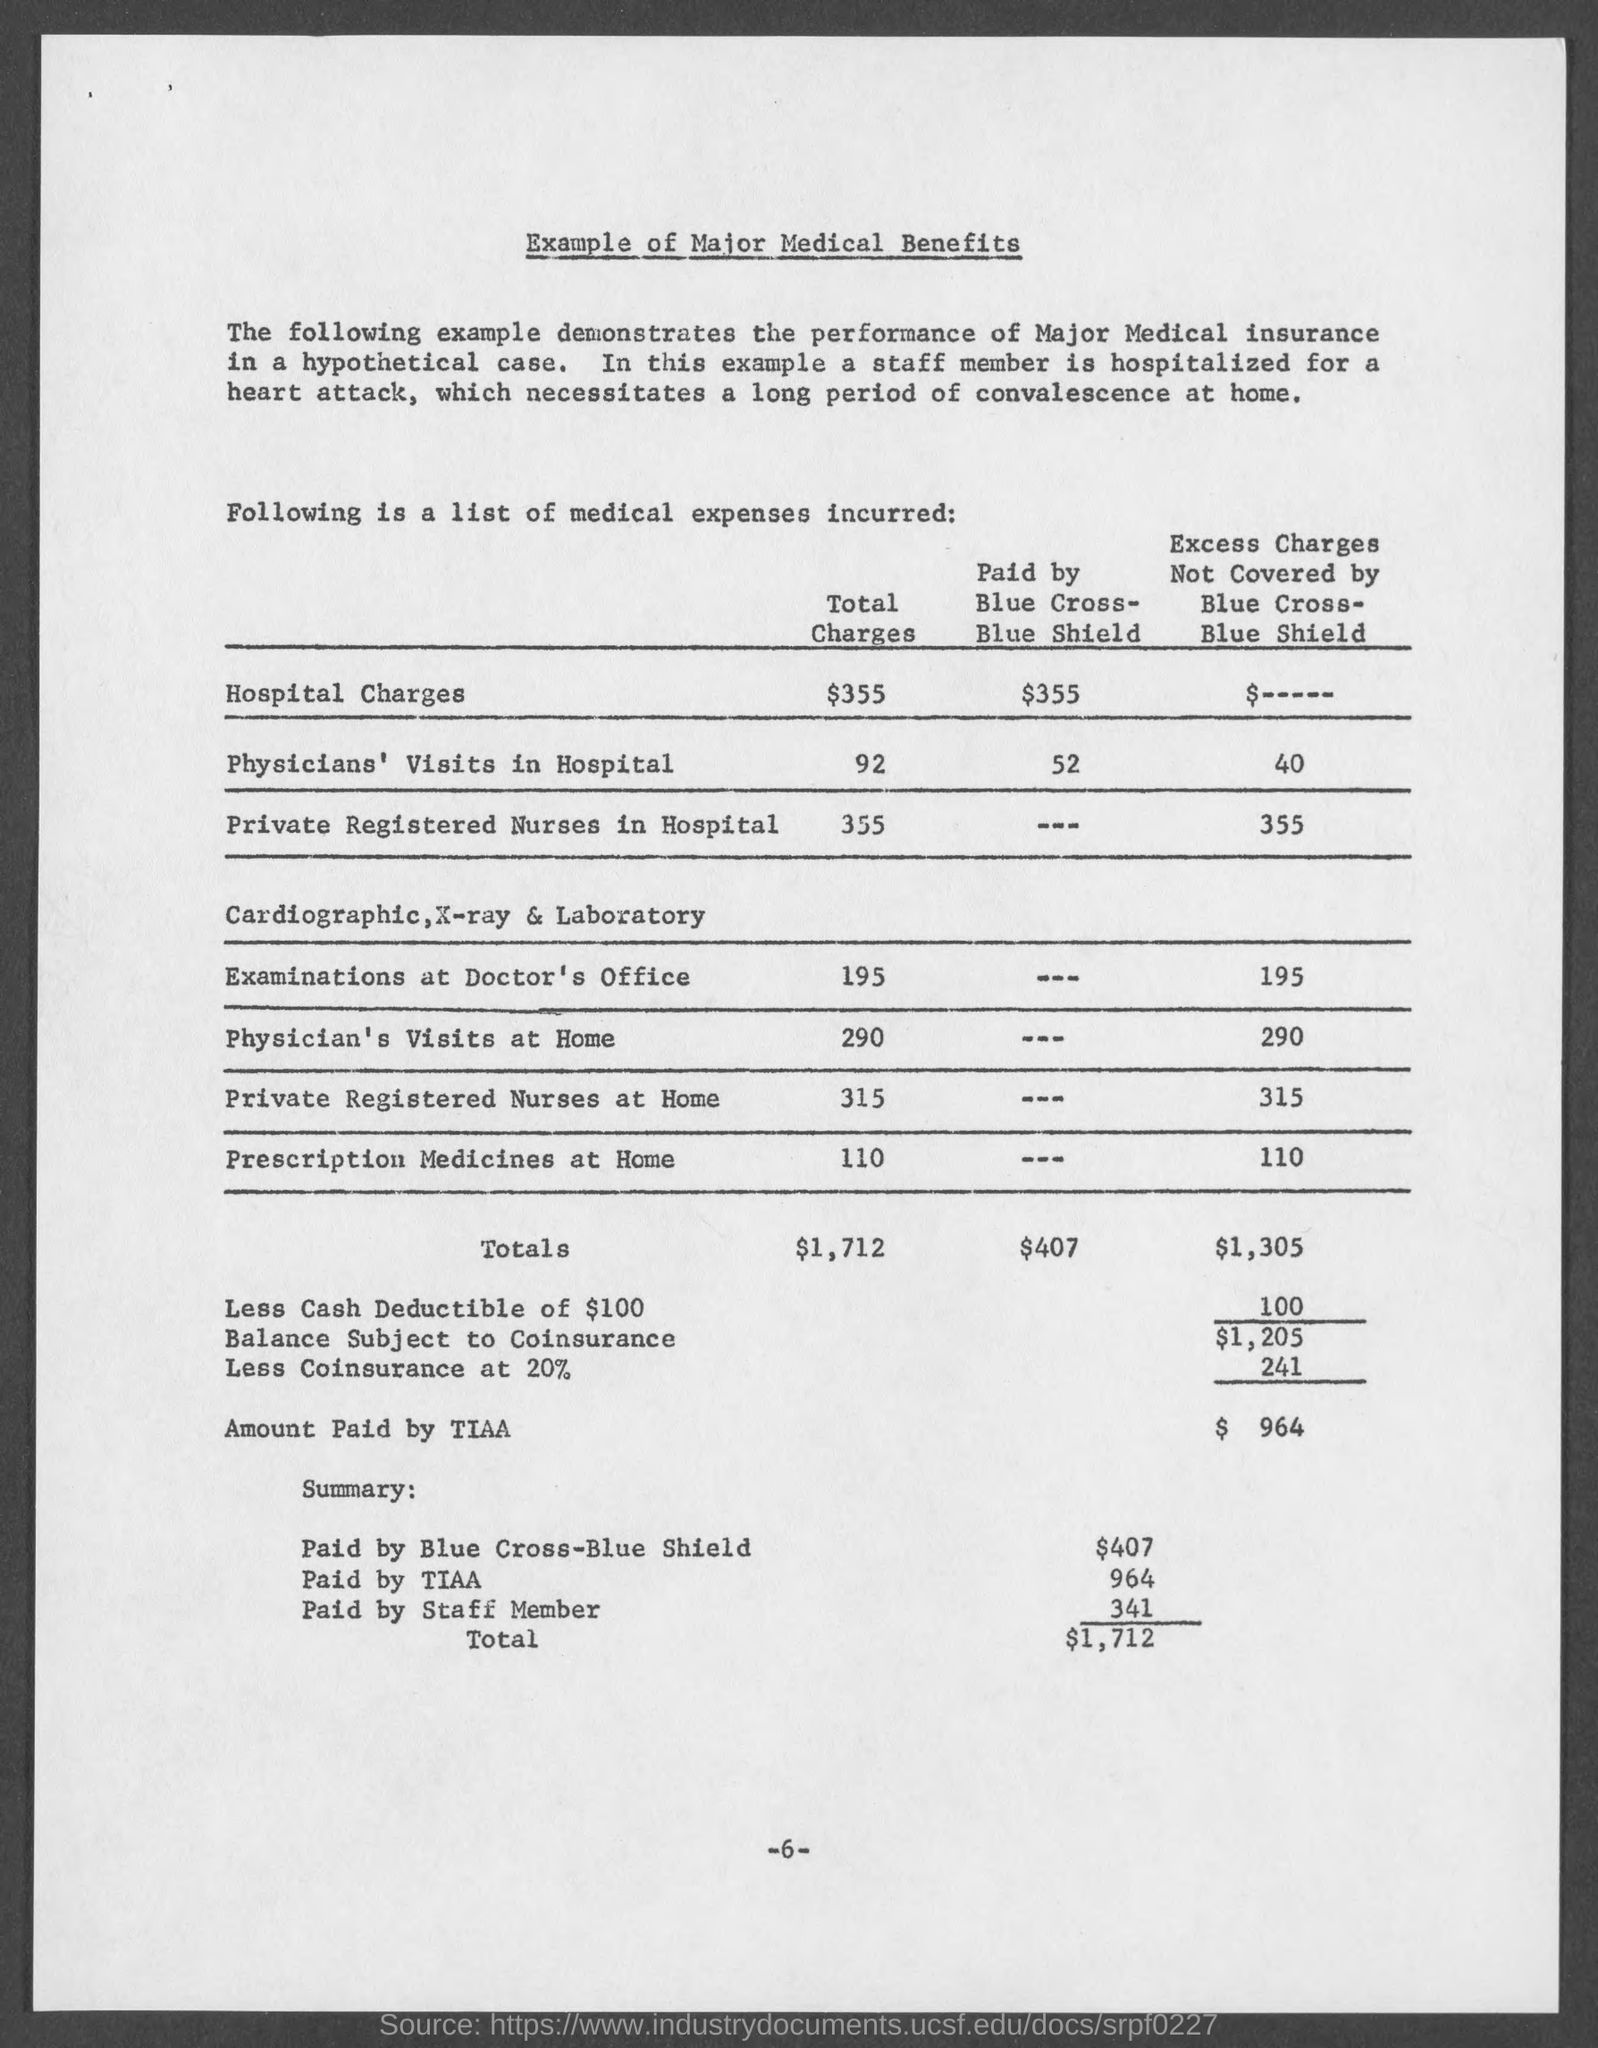Specify some key components in this picture. The total charges for private registered nurses providing care at home is $315. The total charges for private registered nurses in hospitals is 355. The total charges for examinations at the doctor's office are 195. Blue Cross-Blue Shield paid $407. The total charges for physician's visits at home are 290. 